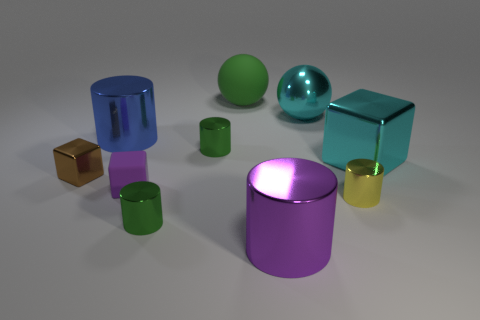How would you interpret the mood or theme conveyed by this arrangement of shapes? The arrangement of shapes with their sleek surfaces and reflective qualities gives off a modern and clean aesthetic. The use of varied, yet harmonious colors could suggest a theme of diversity and unity, where different elements come together to form a balanced and pleasing whole. 